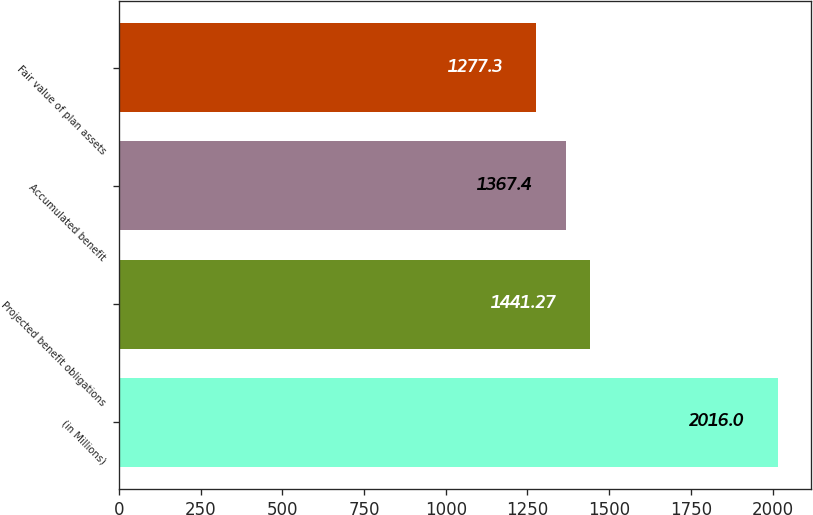Convert chart. <chart><loc_0><loc_0><loc_500><loc_500><bar_chart><fcel>(in Millions)<fcel>Projected benefit obligations<fcel>Accumulated benefit<fcel>Fair value of plan assets<nl><fcel>2016<fcel>1441.27<fcel>1367.4<fcel>1277.3<nl></chart> 